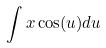<formula> <loc_0><loc_0><loc_500><loc_500>\int x \cos ( u ) d u</formula> 